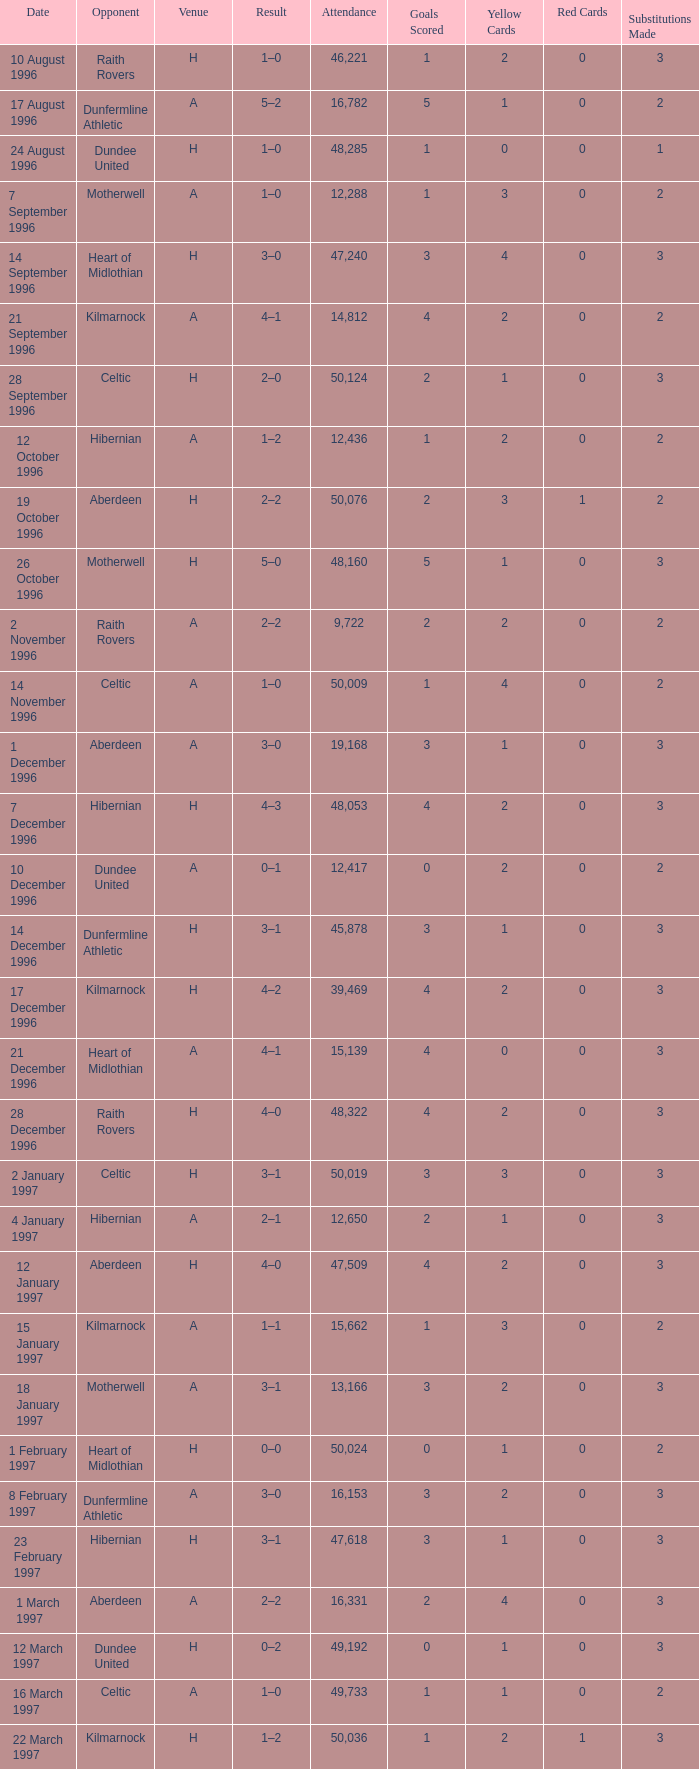When did venue a experience an attendance greater than 48,053, and a score of 1–0? 14 November 1996, 16 March 1997. 